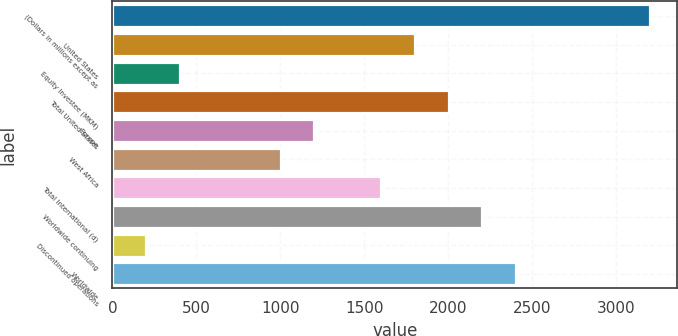Convert chart. <chart><loc_0><loc_0><loc_500><loc_500><bar_chart><fcel>(Dollars in millions except as<fcel>United States<fcel>Equity Investee (MKM)<fcel>Total United States<fcel>Europe<fcel>West Africa<fcel>Total International (d)<fcel>Worldwide continuing<fcel>Discontinued operations<fcel>Worldwide<nl><fcel>3203.24<fcel>1801.84<fcel>400.44<fcel>2002.04<fcel>1201.24<fcel>1001.04<fcel>1601.64<fcel>2202.24<fcel>200.24<fcel>2402.44<nl></chart> 